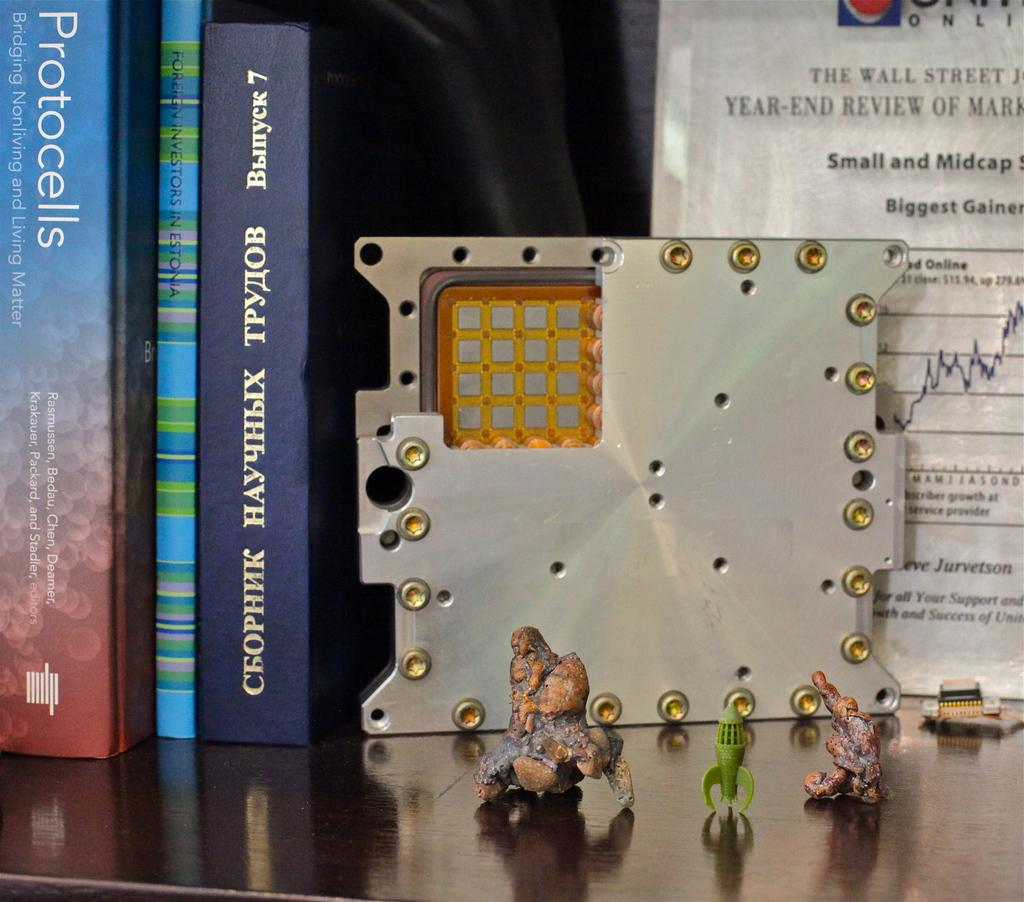<image>
Render a clear and concise summary of the photo. Several books are on a bookshelf. One of the books is titled Protocells. 